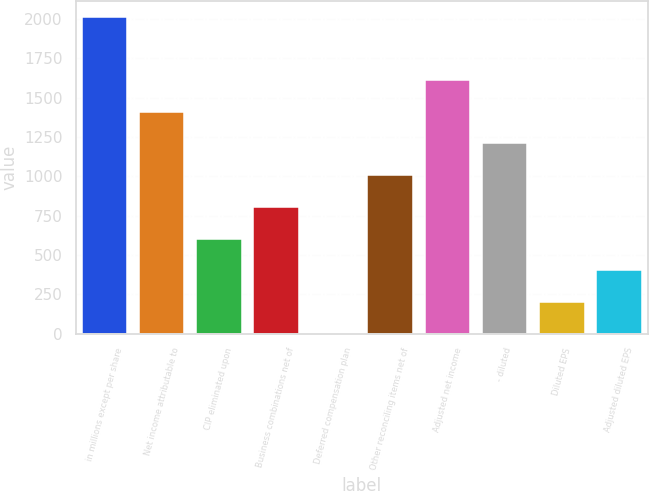<chart> <loc_0><loc_0><loc_500><loc_500><bar_chart><fcel>in millions except per share<fcel>Net income attributable to<fcel>CIP eliminated upon<fcel>Business combinations net of<fcel>Deferred compensation plan<fcel>Other reconciling items net of<fcel>Adjusted net income<fcel>- diluted<fcel>Diluted EPS<fcel>Adjusted diluted EPS<nl><fcel>2014<fcel>1409.89<fcel>604.41<fcel>805.78<fcel>0.3<fcel>1007.15<fcel>1611.26<fcel>1208.52<fcel>201.67<fcel>403.04<nl></chart> 